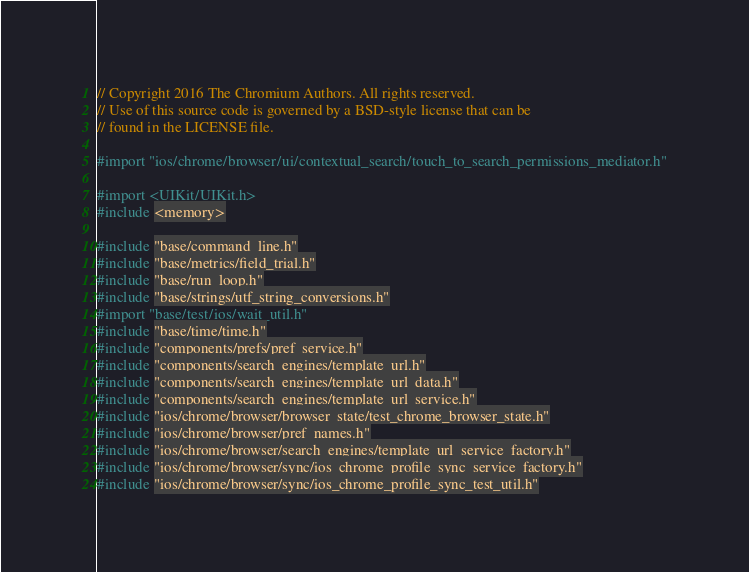Convert code to text. <code><loc_0><loc_0><loc_500><loc_500><_ObjectiveC_>// Copyright 2016 The Chromium Authors. All rights reserved.
// Use of this source code is governed by a BSD-style license that can be
// found in the LICENSE file.

#import "ios/chrome/browser/ui/contextual_search/touch_to_search_permissions_mediator.h"

#import <UIKit/UIKit.h>
#include <memory>

#include "base/command_line.h"
#include "base/metrics/field_trial.h"
#include "base/run_loop.h"
#include "base/strings/utf_string_conversions.h"
#import "base/test/ios/wait_util.h"
#include "base/time/time.h"
#include "components/prefs/pref_service.h"
#include "components/search_engines/template_url.h"
#include "components/search_engines/template_url_data.h"
#include "components/search_engines/template_url_service.h"
#include "ios/chrome/browser/browser_state/test_chrome_browser_state.h"
#include "ios/chrome/browser/pref_names.h"
#include "ios/chrome/browser/search_engines/template_url_service_factory.h"
#include "ios/chrome/browser/sync/ios_chrome_profile_sync_service_factory.h"
#include "ios/chrome/browser/sync/ios_chrome_profile_sync_test_util.h"</code> 